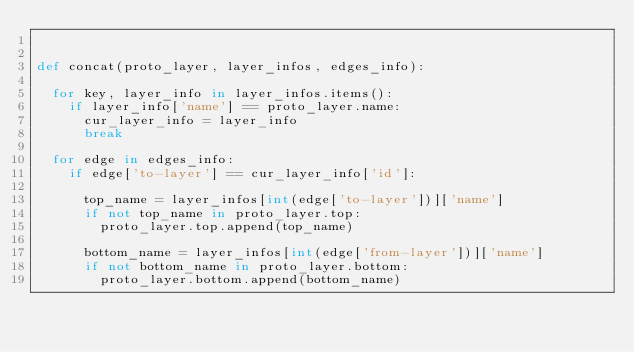Convert code to text. <code><loc_0><loc_0><loc_500><loc_500><_Python_>

def concat(proto_layer, layer_infos, edges_info):
  
  for key, layer_info in layer_infos.items():
    if layer_info['name'] == proto_layer.name:
      cur_layer_info = layer_info
      break
      
  for edge in edges_info:
    if edge['to-layer'] == cur_layer_info['id']:
    
      top_name = layer_infos[int(edge['to-layer'])]['name']
      if not top_name in proto_layer.top:
        proto_layer.top.append(top_name)
        
      bottom_name = layer_infos[int(edge['from-layer'])]['name']
      if not bottom_name in proto_layer.bottom:
        proto_layer.bottom.append(bottom_name)</code> 